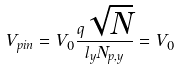Convert formula to latex. <formula><loc_0><loc_0><loc_500><loc_500>V _ { p i n } = V _ { 0 } \frac { q \sqrt { N } } { l _ { y } N _ { p , y } } = V _ { 0 }</formula> 